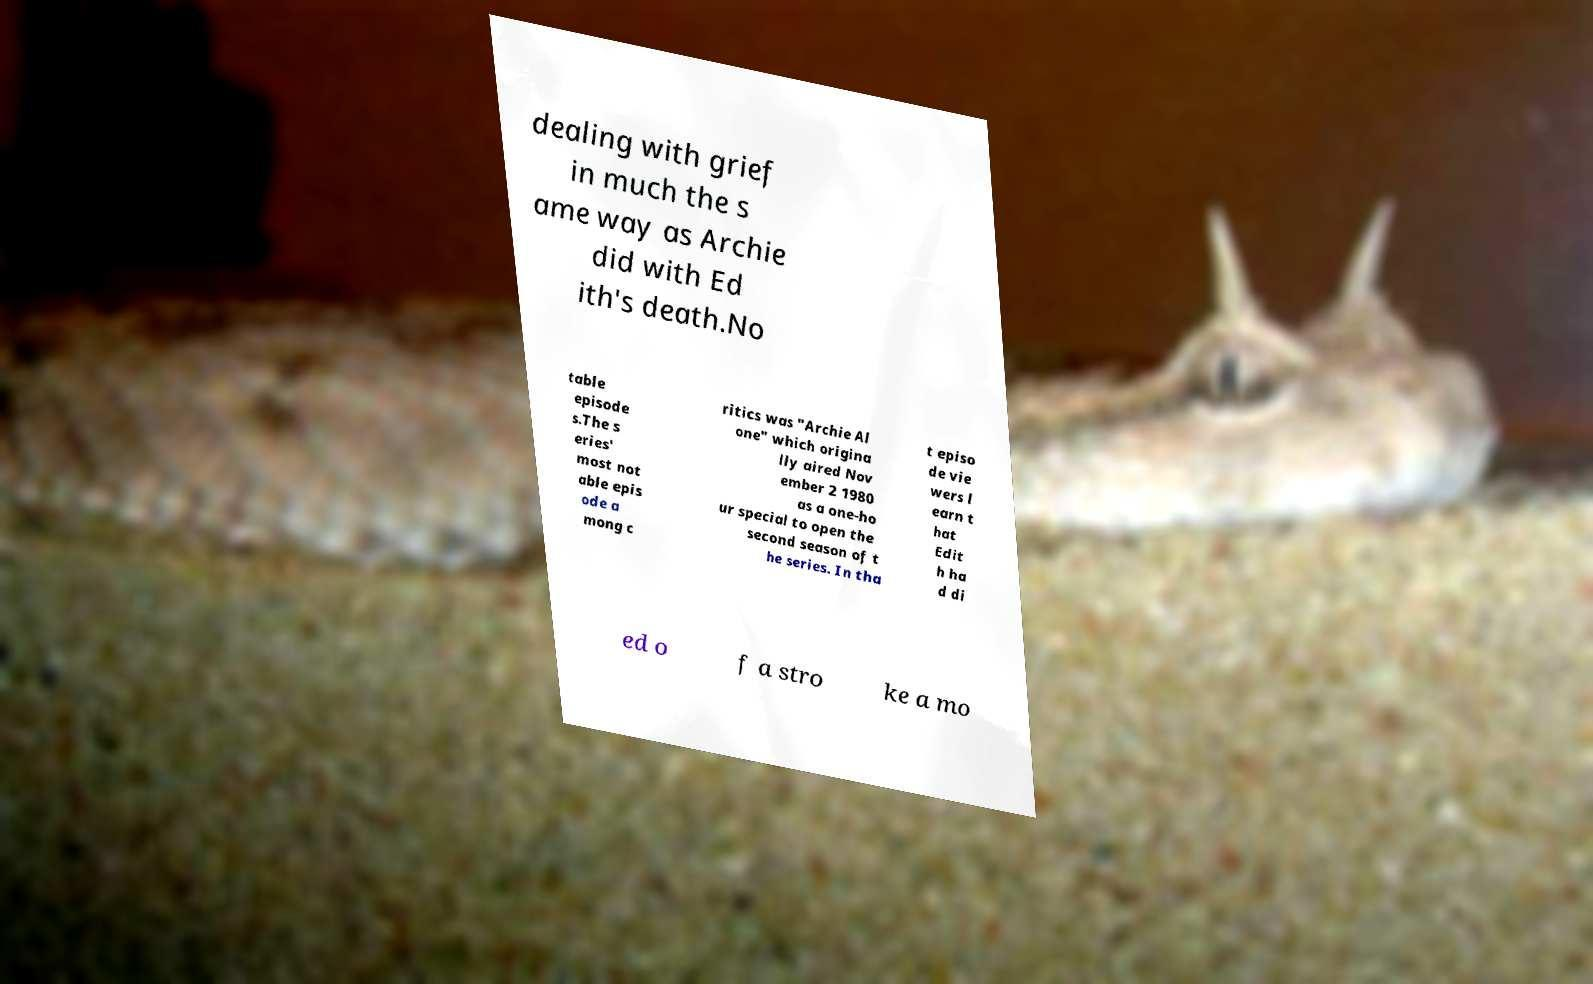For documentation purposes, I need the text within this image transcribed. Could you provide that? dealing with grief in much the s ame way as Archie did with Ed ith's death.No table episode s.The s eries' most not able epis ode a mong c ritics was "Archie Al one" which origina lly aired Nov ember 2 1980 as a one-ho ur special to open the second season of t he series. In tha t episo de vie wers l earn t hat Edit h ha d di ed o f a stro ke a mo 